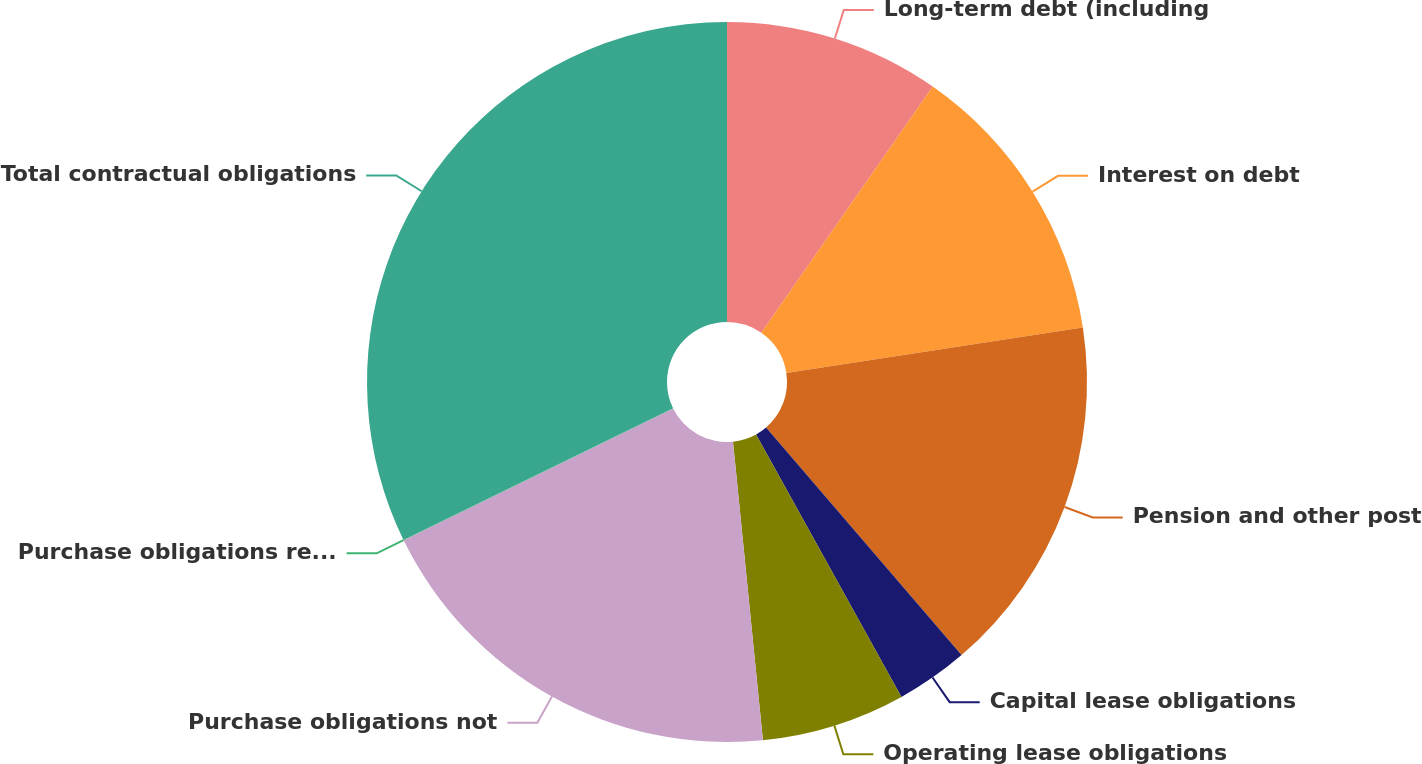Convert chart. <chart><loc_0><loc_0><loc_500><loc_500><pie_chart><fcel>Long-term debt (including<fcel>Interest on debt<fcel>Pension and other post<fcel>Capital lease obligations<fcel>Operating lease obligations<fcel>Purchase obligations not<fcel>Purchase obligations recorded<fcel>Total contractual obligations<nl><fcel>9.68%<fcel>12.9%<fcel>16.12%<fcel>3.24%<fcel>6.46%<fcel>19.34%<fcel>0.02%<fcel>32.22%<nl></chart> 